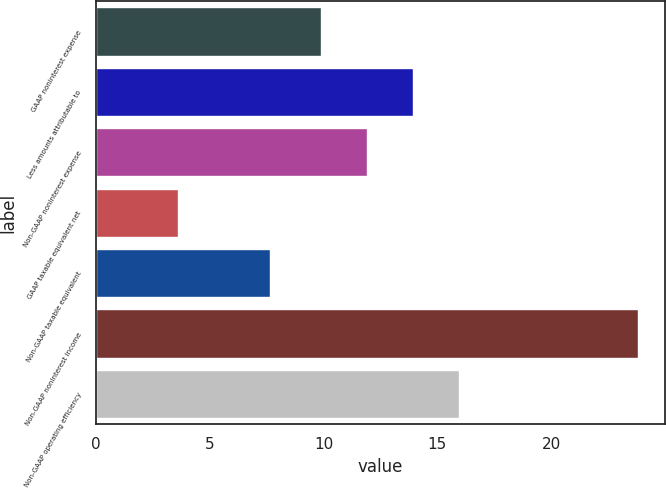Convert chart. <chart><loc_0><loc_0><loc_500><loc_500><bar_chart><fcel>GAAP noninterest expense<fcel>Less amounts attributable to<fcel>Non-GAAP noninterest expense<fcel>GAAP taxable equivalent net<fcel>Non-GAAP taxable equivalent<fcel>Non-GAAP noninterest income<fcel>Non-GAAP operating efficiency<nl><fcel>9.9<fcel>13.94<fcel>11.92<fcel>3.6<fcel>7.64<fcel>23.8<fcel>15.96<nl></chart> 